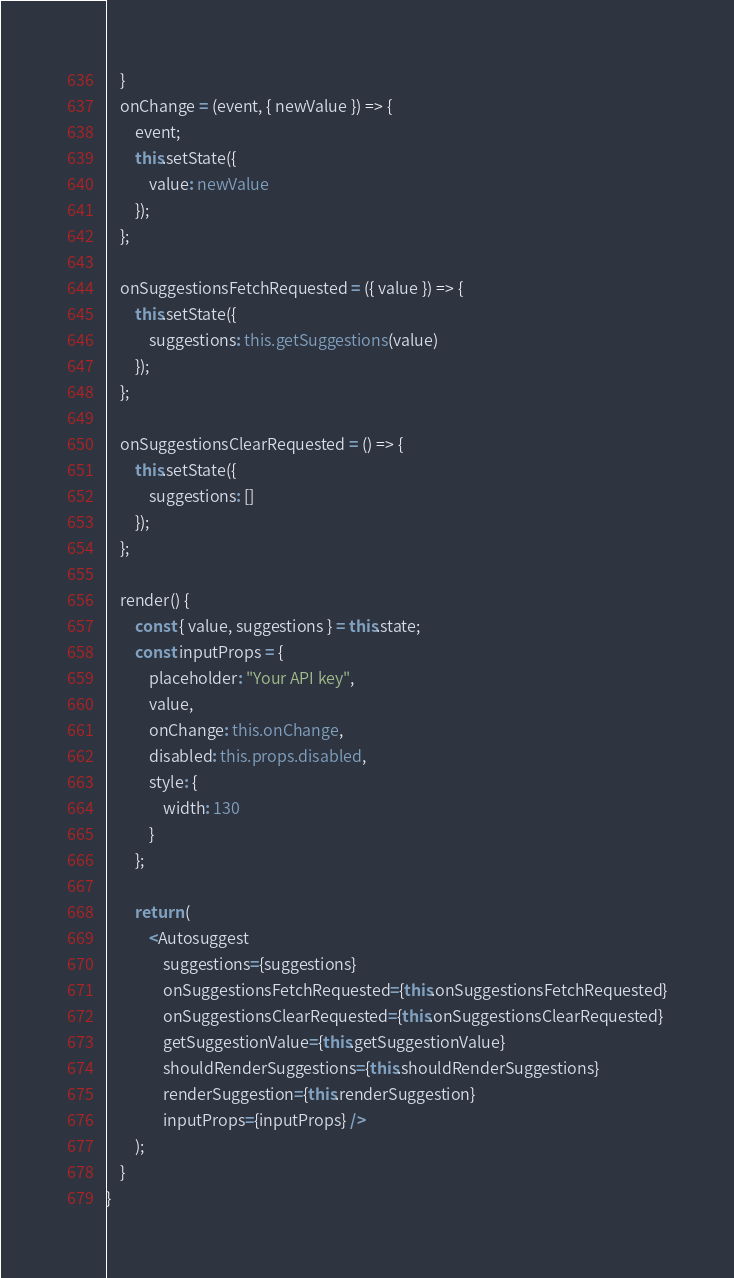Convert code to text. <code><loc_0><loc_0><loc_500><loc_500><_TypeScript_>    }
    onChange = (event, { newValue }) => {
        event;
        this.setState({
            value: newValue
        });
    };

    onSuggestionsFetchRequested = ({ value }) => {
        this.setState({
            suggestions: this.getSuggestions(value)
        });
    };

    onSuggestionsClearRequested = () => {
        this.setState({
            suggestions: []
        });
    };

    render() {
        const { value, suggestions } = this.state;
        const inputProps = {
            placeholder: "Your API key",
            value,
            onChange: this.onChange,
            disabled: this.props.disabled,
            style: {
                width: 130
            }
        };

        return (
            <Autosuggest
                suggestions={suggestions}
                onSuggestionsFetchRequested={this.onSuggestionsFetchRequested}
                onSuggestionsClearRequested={this.onSuggestionsClearRequested}
                getSuggestionValue={this.getSuggestionValue}
                shouldRenderSuggestions={this.shouldRenderSuggestions}
                renderSuggestion={this.renderSuggestion}
                inputProps={inputProps} />
        );
    }
}</code> 